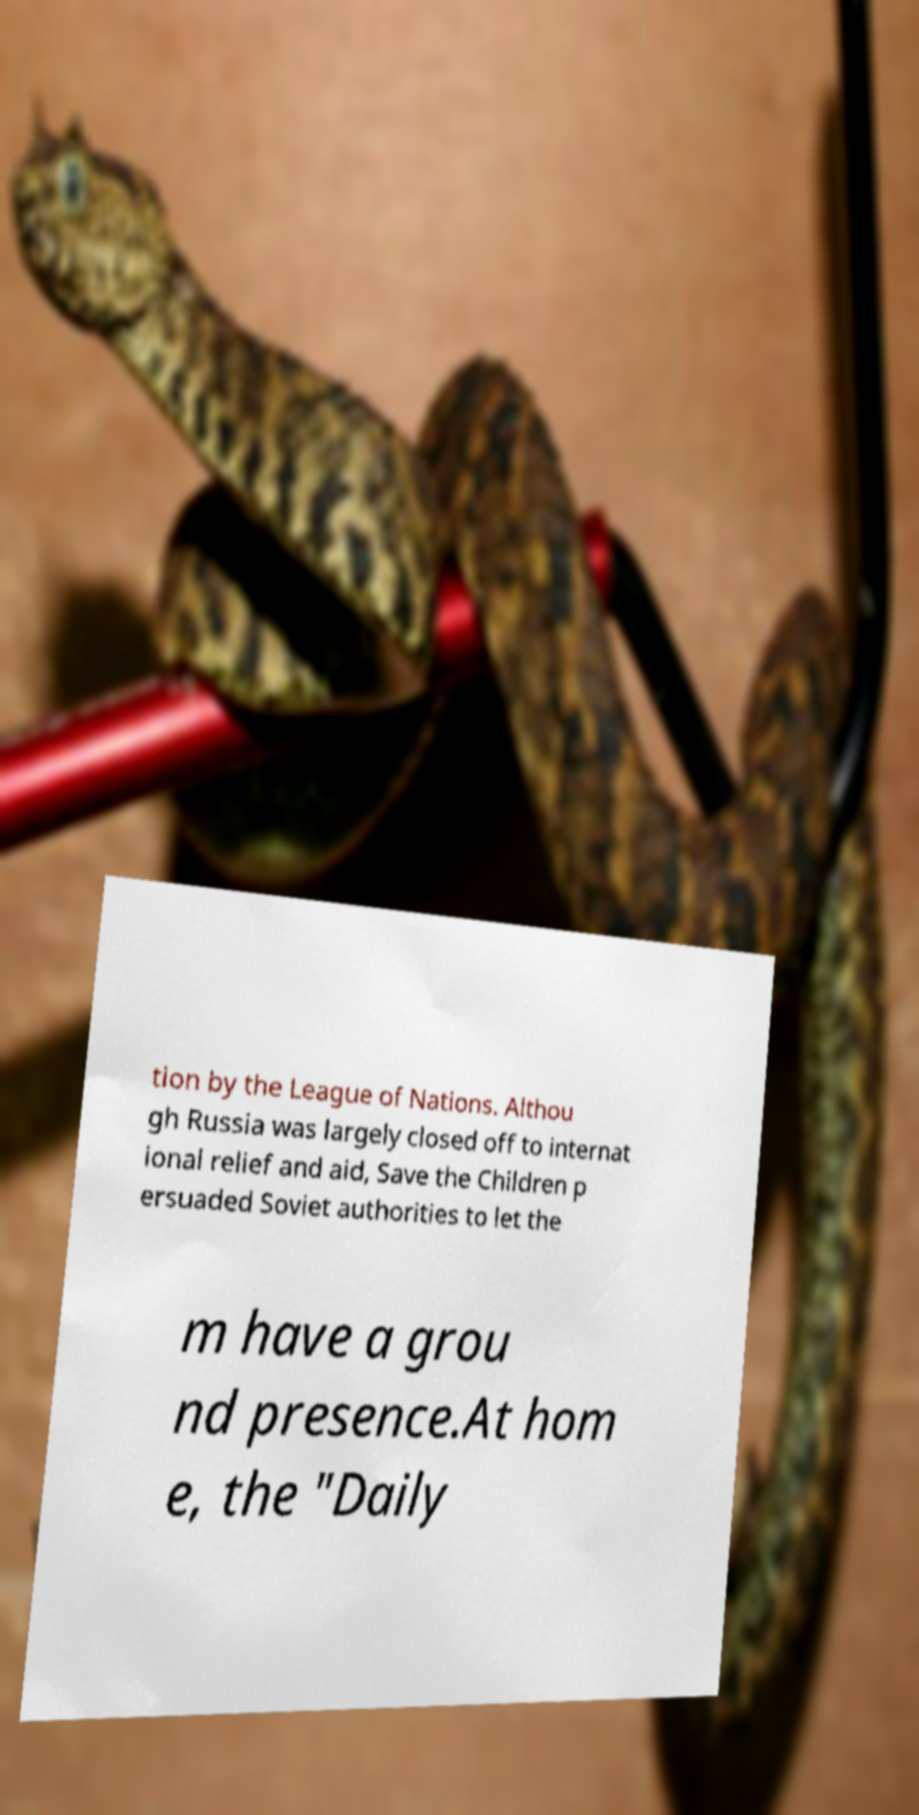Could you assist in decoding the text presented in this image and type it out clearly? tion by the League of Nations. Althou gh Russia was largely closed off to internat ional relief and aid, Save the Children p ersuaded Soviet authorities to let the m have a grou nd presence.At hom e, the "Daily 